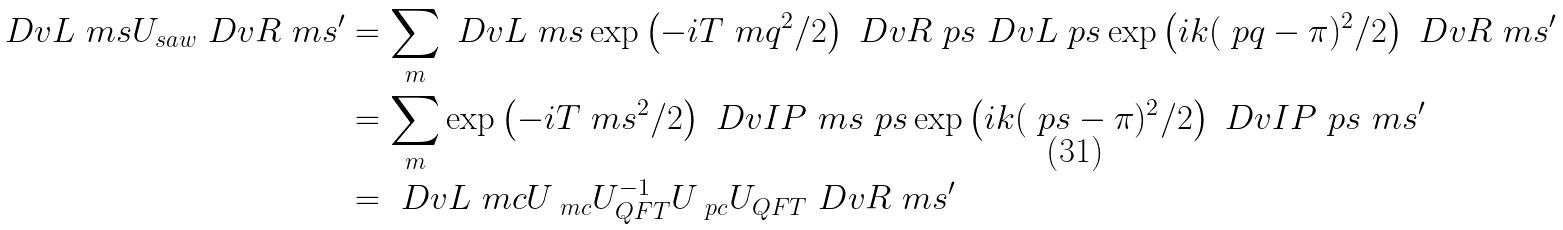Convert formula to latex. <formula><loc_0><loc_0><loc_500><loc_500>\ D v L { \ m s } U _ { s a w } \ D v R { \ m s ^ { \prime } } & = \sum _ { m } \ D v L { \ m s } \exp \left ( - i T \ m q ^ { 2 } / 2 \right ) \ D v R { \ p s } \ D v L { \ p s } \exp \left ( i k ( \ p q - \pi ) ^ { 2 } / 2 \right ) \ D v R { \ m s ^ { \prime } } \\ & = \sum _ { m } \exp \left ( - i T \ m s ^ { 2 } / 2 \right ) \ D v I P { \ m s } { \ p s } \exp \left ( i k ( \ p s - \pi ) ^ { 2 } / 2 \right ) \ D v I P { \ p s } { \ m s ^ { \prime } } \\ & = \ D v L { \ m c } U _ { \ m c } U _ { Q F T } ^ { - 1 } U _ { \ p c } U _ { Q F T } \ D v R { \ m s ^ { \prime } }</formula> 